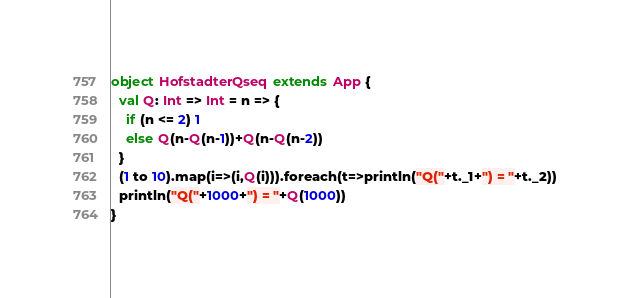<code> <loc_0><loc_0><loc_500><loc_500><_Scala_>object HofstadterQseq extends App {
  val Q: Int => Int = n => {
    if (n <= 2) 1
    else Q(n-Q(n-1))+Q(n-Q(n-2))
  }
  (1 to 10).map(i=>(i,Q(i))).foreach(t=>println("Q("+t._1+") = "+t._2))
  println("Q("+1000+") = "+Q(1000))
}
</code> 